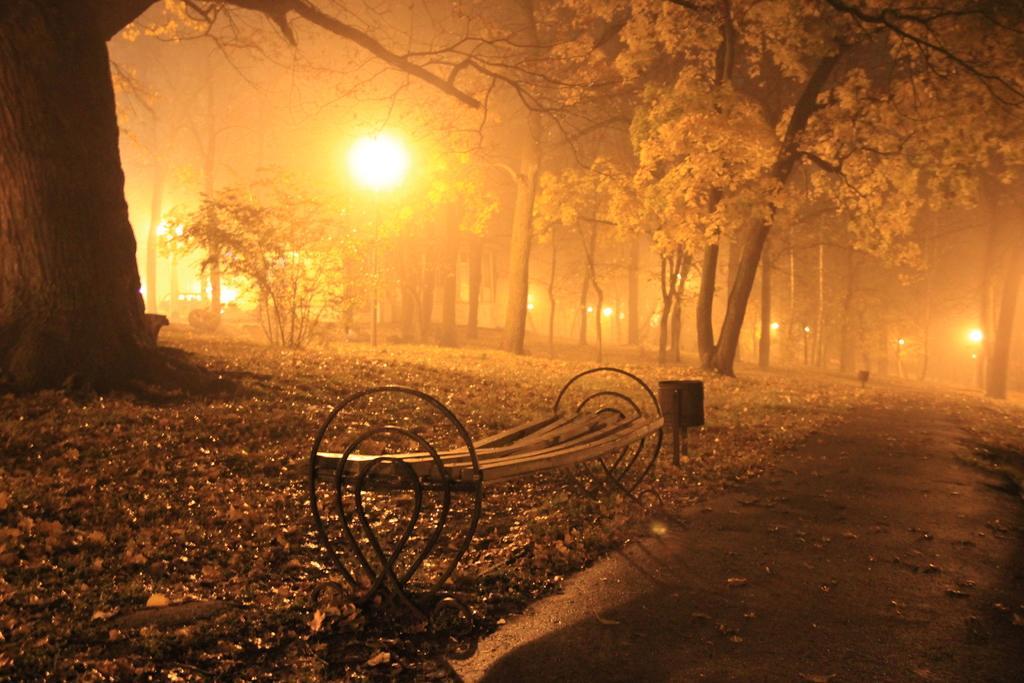How would you summarize this image in a sentence or two? In the image in the center, we can see one bench and one pole. In the background we can see trees and lights. 